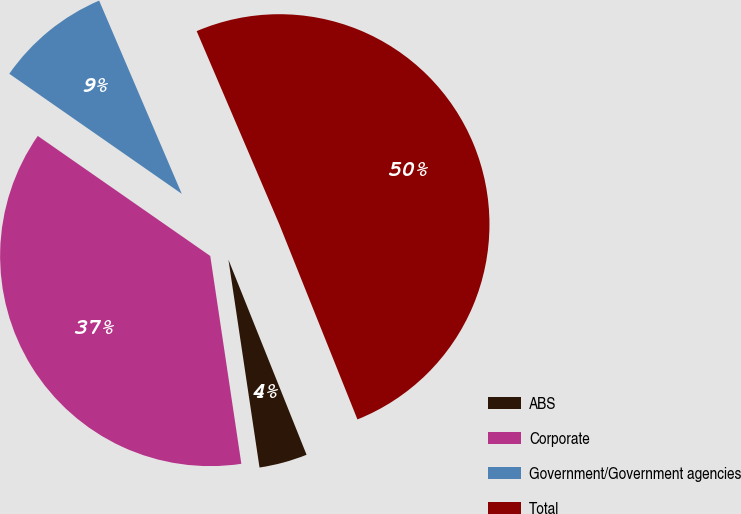Convert chart. <chart><loc_0><loc_0><loc_500><loc_500><pie_chart><fcel>ABS<fcel>Corporate<fcel>Government/Government agencies<fcel>Total<nl><fcel>3.7%<fcel>37.04%<fcel>8.89%<fcel>50.37%<nl></chart> 